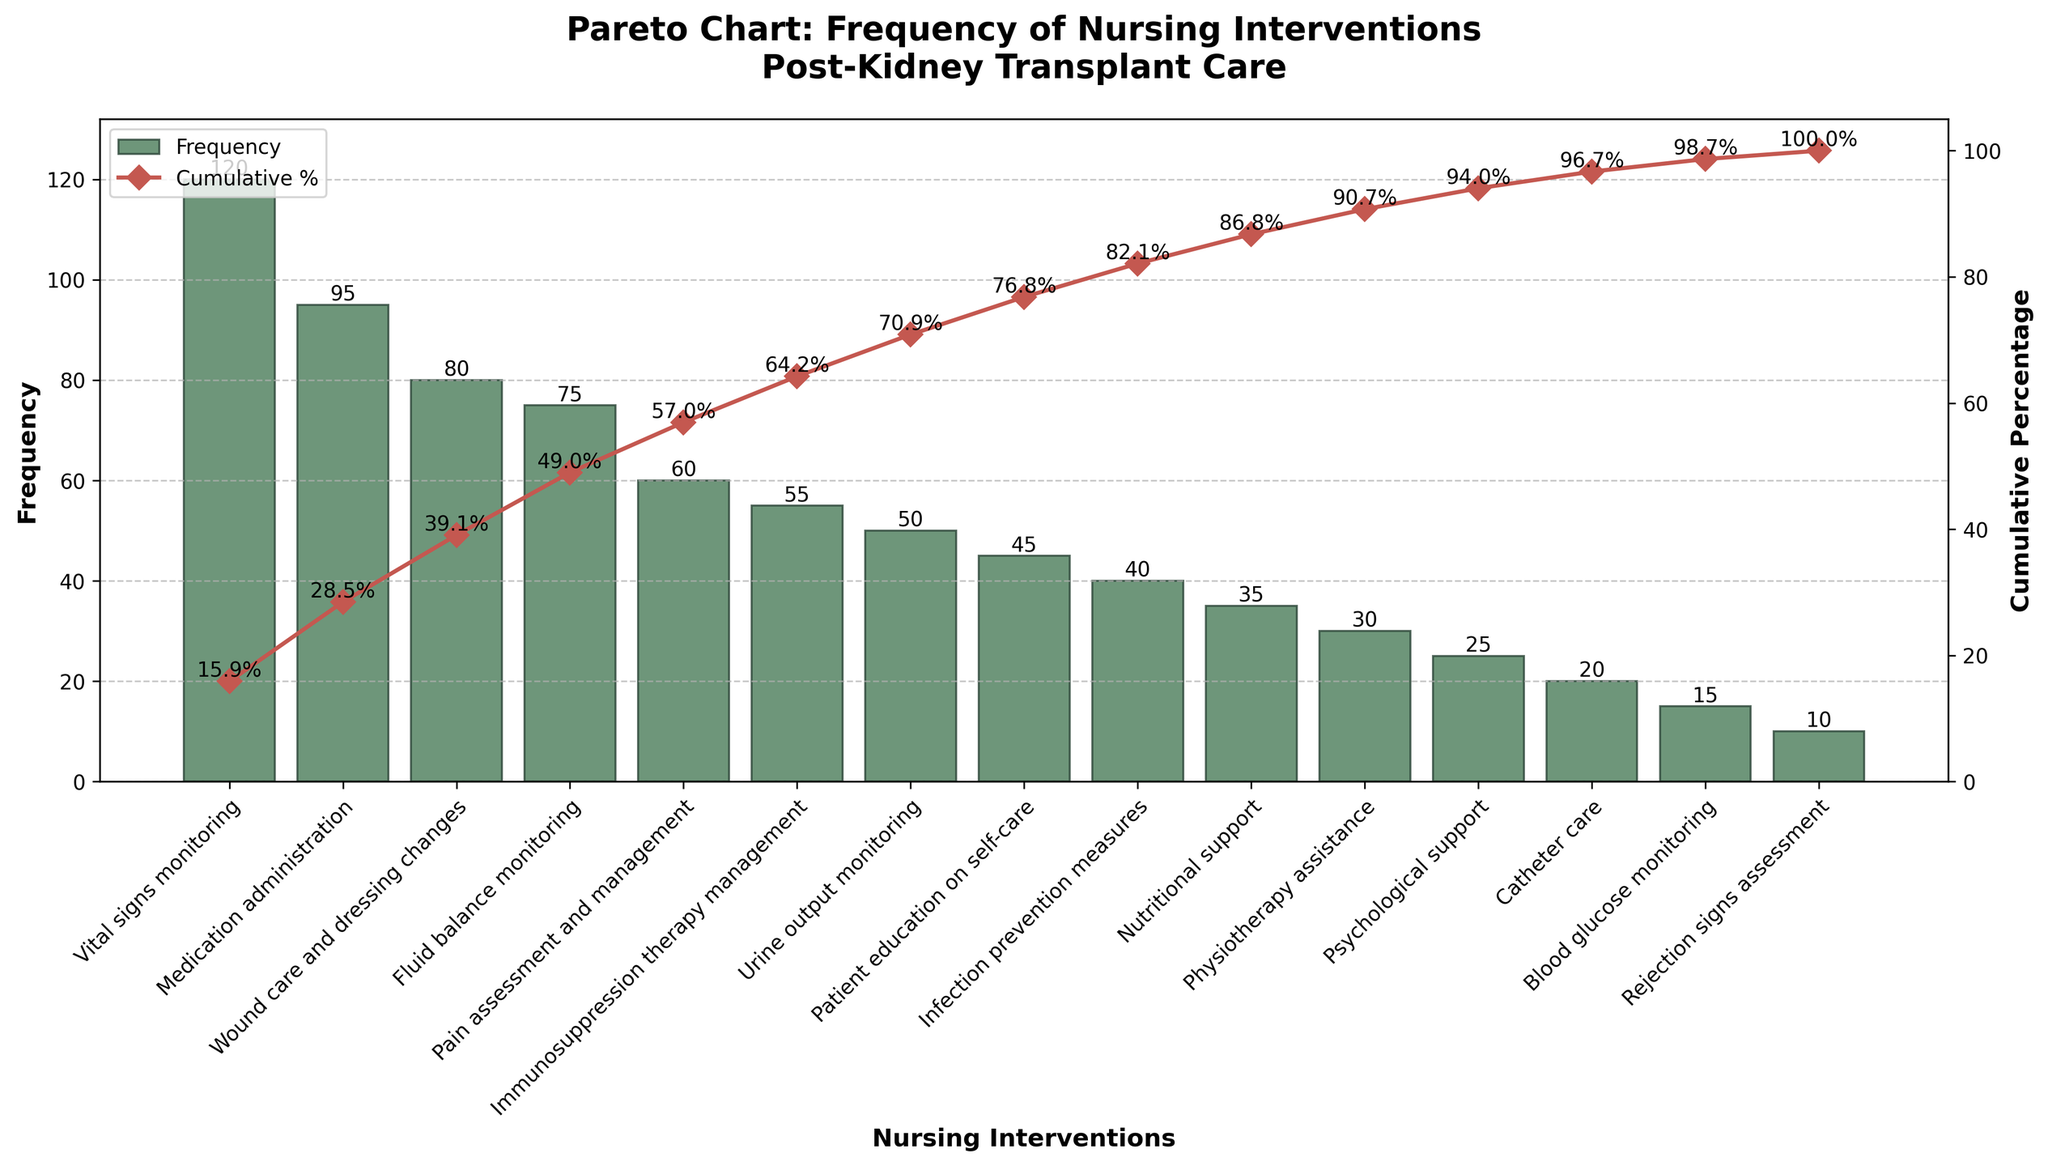What is the most frequent nursing intervention performed on post-operative kidney transplant patients? The tallest bar represents the most frequent intervention, which is 'Vital signs monitoring' with a frequency of 120.
Answer: Vital signs monitoring What is the cumulative percentage after the first three nursing interventions? The cumulative percentage after 'Vital signs monitoring', 'Medication administration', and 'Wound care and dressing changes' is shown as 46.02% at the third point on the cumulative line.
Answer: 46.02% Which nursing intervention has a frequency of 50? The height of the bar for 'Urine output monitoring' matches 50.
Answer: Urine output monitoring What is the title of the Pareto chart? The title is displayed at the top of the chart and reads 'Pareto Chart: Frequency of Nursing Interventions Post-Kidney Transplant Care'.
Answer: Pareto Chart: Frequency of Nursing Interventions Post-Kidney Transplant Care How many nursing interventions have a cumulative percentage above 80%? By following the cumulative percentage line, the interventions from 'Vital signs monitoring' to 'Catheter care' cover above 80%, making it 12 interventions.
Answer: 12 Which is more frequent: 'Pain assessment and management' or 'Immunosuppression therapy management'? 'Pain assessment and management' has a higher bar height (60) as compared to 'Immunosuppression therapy management' (55).
Answer: Pain assessment and management What is the frequency of the least frequent intervention? The shortest bar represents 'Rejection signs assessment' with a frequency of 10.
Answer: 10 What percentage of interventions cover 50% of the cumulative percentage? By locating 50% on the cumulative percentage axis, it reaches just past 'Wound care and dressing changes', which means after the first three interventions.
Answer: 3 interventions How does the frequency of 'Patient education on self-care' compare to 'Nutritional support'? 'Patient education on self-care' has a bar height of 45, while 'Nutritional support' has a height of 35, making 'Patient education on self-care' more frequent.
Answer: Patient education on self-care What are the x-axis and y-axis labels of the chart? The x-axis is labeled 'Nursing Interventions', and the first y-axis is labeled 'Frequency'. The secondary y-axis on the right is labeled 'Cumulative Percentage'.
Answer: Nursing Interventions, Frequency, Cumulative Percentage 